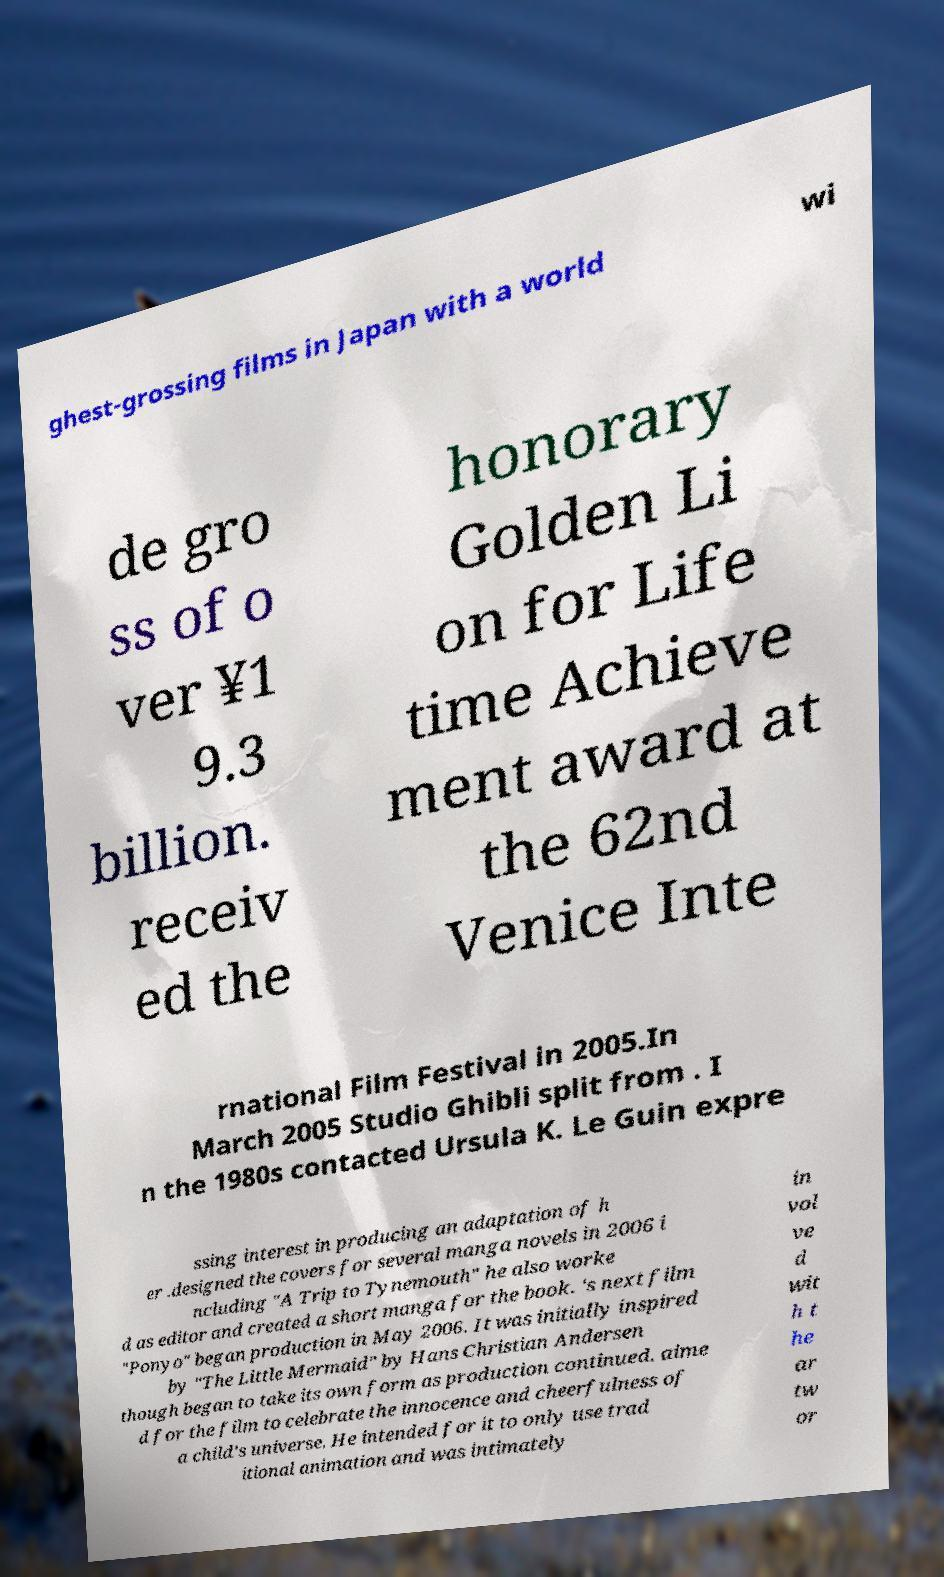Please identify and transcribe the text found in this image. ghest-grossing films in Japan with a world wi de gro ss of o ver ¥1 9.3 billion. receiv ed the honorary Golden Li on for Life time Achieve ment award at the 62nd Venice Inte rnational Film Festival in 2005.In March 2005 Studio Ghibli split from . I n the 1980s contacted Ursula K. Le Guin expre ssing interest in producing an adaptation of h er .designed the covers for several manga novels in 2006 i ncluding "A Trip to Tynemouth" he also worke d as editor and created a short manga for the book. 's next film "Ponyo" began production in May 2006. It was initially inspired by "The Little Mermaid" by Hans Christian Andersen though began to take its own form as production continued. aime d for the film to celebrate the innocence and cheerfulness of a child's universe. He intended for it to only use trad itional animation and was intimately in vol ve d wit h t he ar tw or 